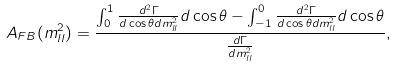<formula> <loc_0><loc_0><loc_500><loc_500>A _ { F B } ( m _ { l l } ^ { 2 } ) = \frac { \int _ { 0 } ^ { 1 } \frac { d ^ { 2 } \Gamma } { d \cos \theta d m _ { l l } ^ { 2 } } d \cos \theta - \int _ { - 1 } ^ { 0 } \frac { d ^ { 2 } \Gamma } { d \cos \theta d m _ { l l } ^ { 2 } } d \cos \theta } { \frac { d \Gamma } { d m _ { l l } ^ { 2 } } } ,</formula> 